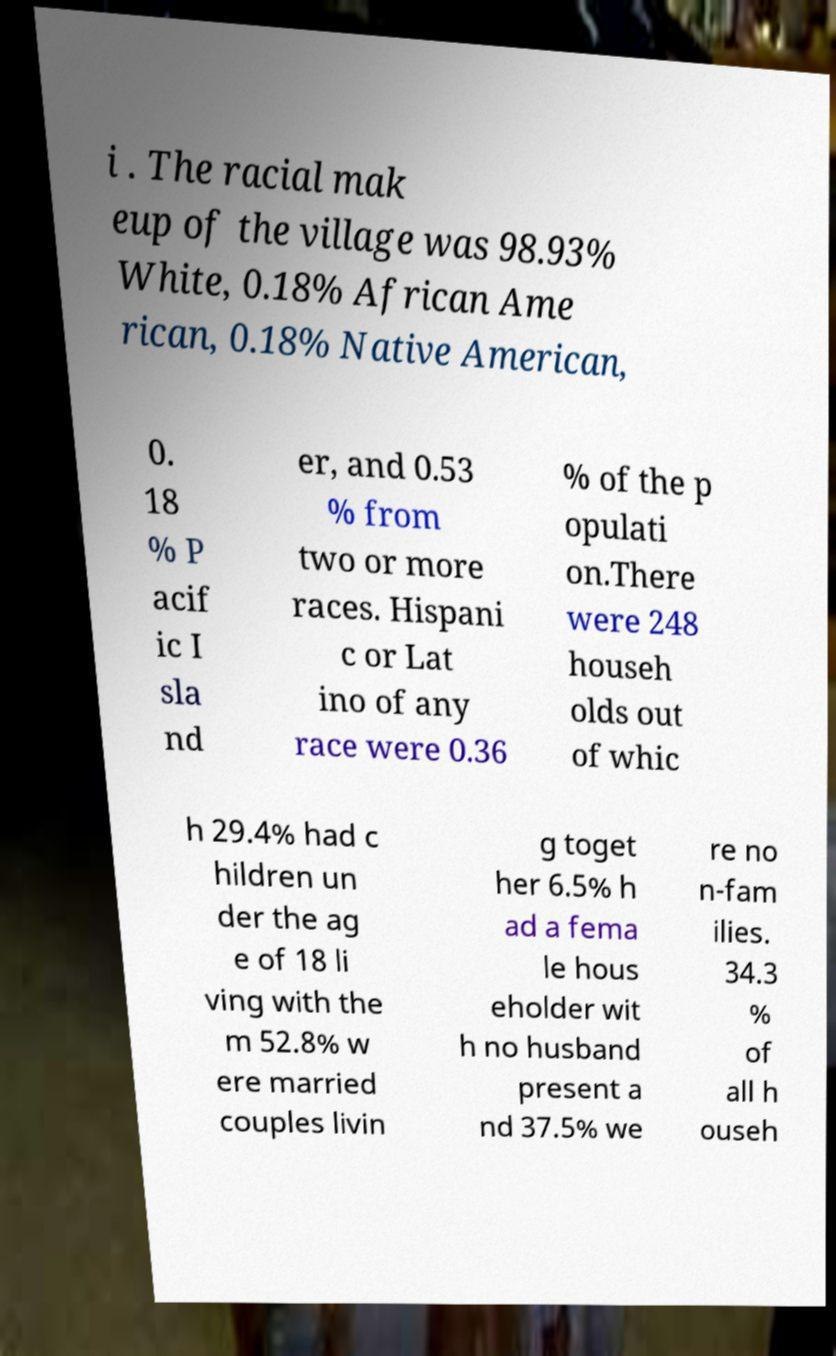I need the written content from this picture converted into text. Can you do that? i . The racial mak eup of the village was 98.93% White, 0.18% African Ame rican, 0.18% Native American, 0. 18 % P acif ic I sla nd er, and 0.53 % from two or more races. Hispani c or Lat ino of any race were 0.36 % of the p opulati on.There were 248 househ olds out of whic h 29.4% had c hildren un der the ag e of 18 li ving with the m 52.8% w ere married couples livin g toget her 6.5% h ad a fema le hous eholder wit h no husband present a nd 37.5% we re no n-fam ilies. 34.3 % of all h ouseh 